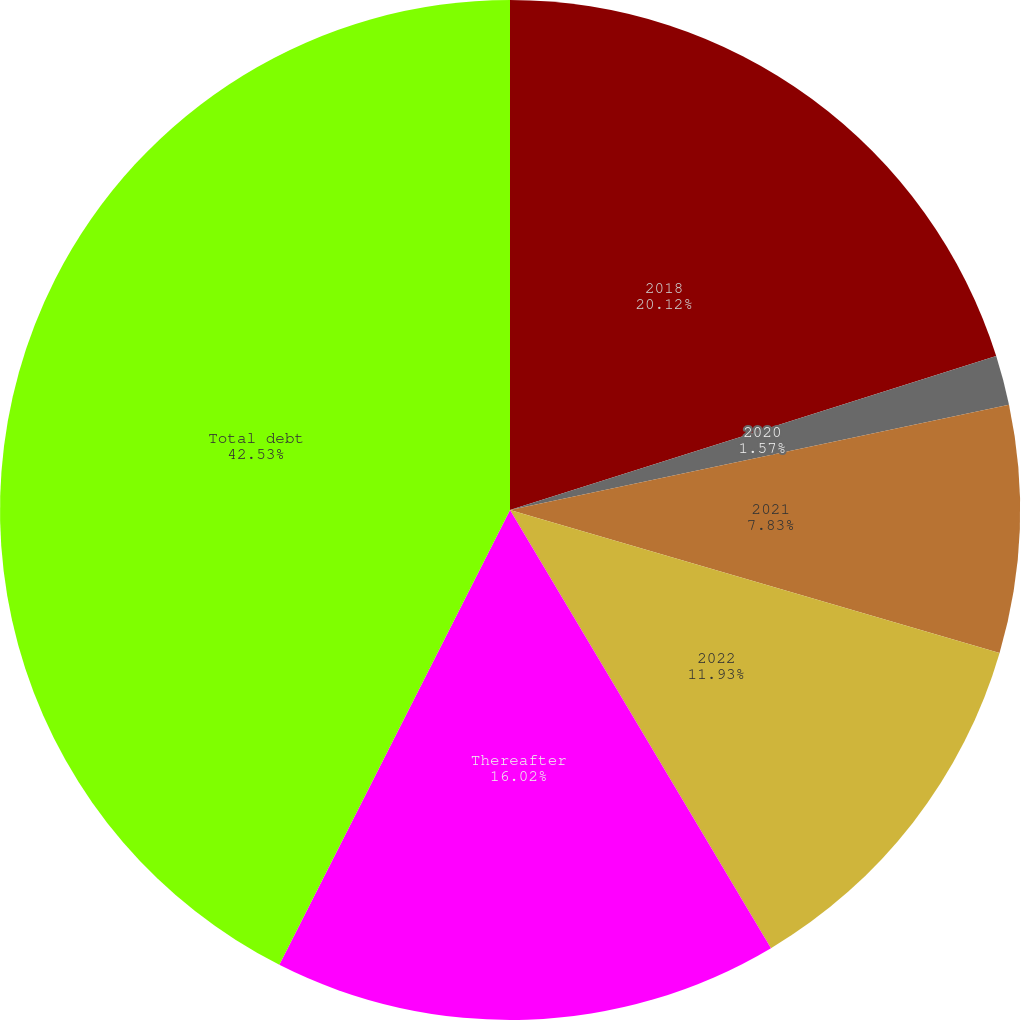Convert chart. <chart><loc_0><loc_0><loc_500><loc_500><pie_chart><fcel>2018<fcel>2020<fcel>2021<fcel>2022<fcel>Thereafter<fcel>Total debt<nl><fcel>20.12%<fcel>1.57%<fcel>7.83%<fcel>11.93%<fcel>16.02%<fcel>42.53%<nl></chart> 